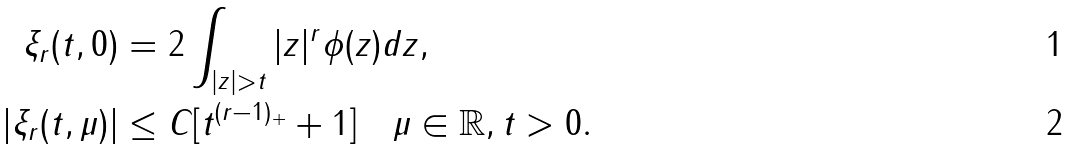Convert formula to latex. <formula><loc_0><loc_0><loc_500><loc_500>\xi _ { r } ( t , 0 ) & = 2 \int _ { | z | > t } | z | ^ { r } \phi ( z ) d z , \\ | \xi _ { r } ( t , \mu ) | & \leq C [ t ^ { ( r - 1 ) _ { + } } + 1 ] \quad \mu \in \mathbb { R } , t > 0 .</formula> 